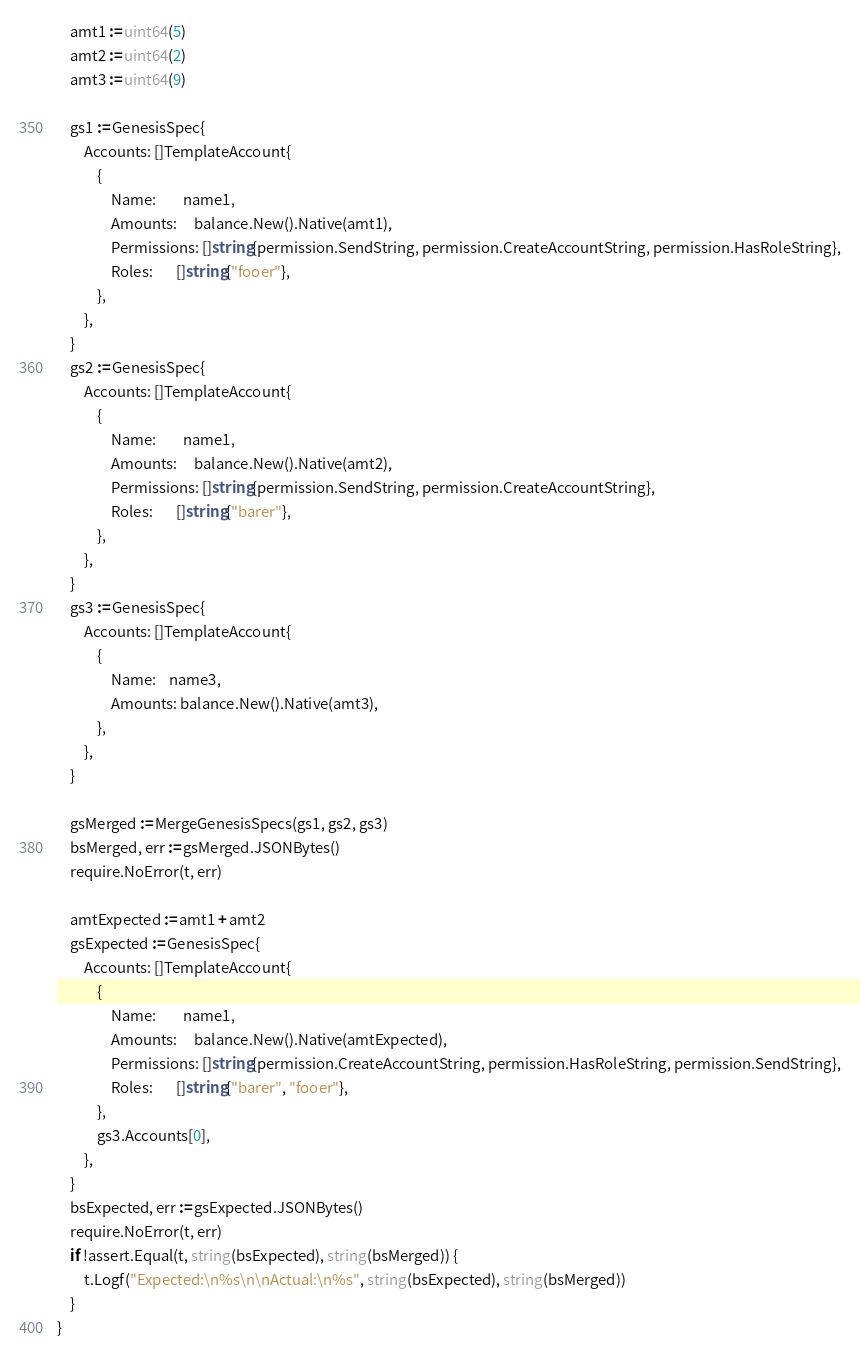Convert code to text. <code><loc_0><loc_0><loc_500><loc_500><_Go_>
	amt1 := uint64(5)
	amt2 := uint64(2)
	amt3 := uint64(9)

	gs1 := GenesisSpec{
		Accounts: []TemplateAccount{
			{
				Name:        name1,
				Amounts:     balance.New().Native(amt1),
				Permissions: []string{permission.SendString, permission.CreateAccountString, permission.HasRoleString},
				Roles:       []string{"fooer"},
			},
		},
	}
	gs2 := GenesisSpec{
		Accounts: []TemplateAccount{
			{
				Name:        name1,
				Amounts:     balance.New().Native(amt2),
				Permissions: []string{permission.SendString, permission.CreateAccountString},
				Roles:       []string{"barer"},
			},
		},
	}
	gs3 := GenesisSpec{
		Accounts: []TemplateAccount{
			{
				Name:    name3,
				Amounts: balance.New().Native(amt3),
			},
		},
	}

	gsMerged := MergeGenesisSpecs(gs1, gs2, gs3)
	bsMerged, err := gsMerged.JSONBytes()
	require.NoError(t, err)

	amtExpected := amt1 + amt2
	gsExpected := GenesisSpec{
		Accounts: []TemplateAccount{
			{
				Name:        name1,
				Amounts:     balance.New().Native(amtExpected),
				Permissions: []string{permission.CreateAccountString, permission.HasRoleString, permission.SendString},
				Roles:       []string{"barer", "fooer"},
			},
			gs3.Accounts[0],
		},
	}
	bsExpected, err := gsExpected.JSONBytes()
	require.NoError(t, err)
	if !assert.Equal(t, string(bsExpected), string(bsMerged)) {
		t.Logf("Expected:\n%s\n\nActual:\n%s", string(bsExpected), string(bsMerged))
	}
}
</code> 